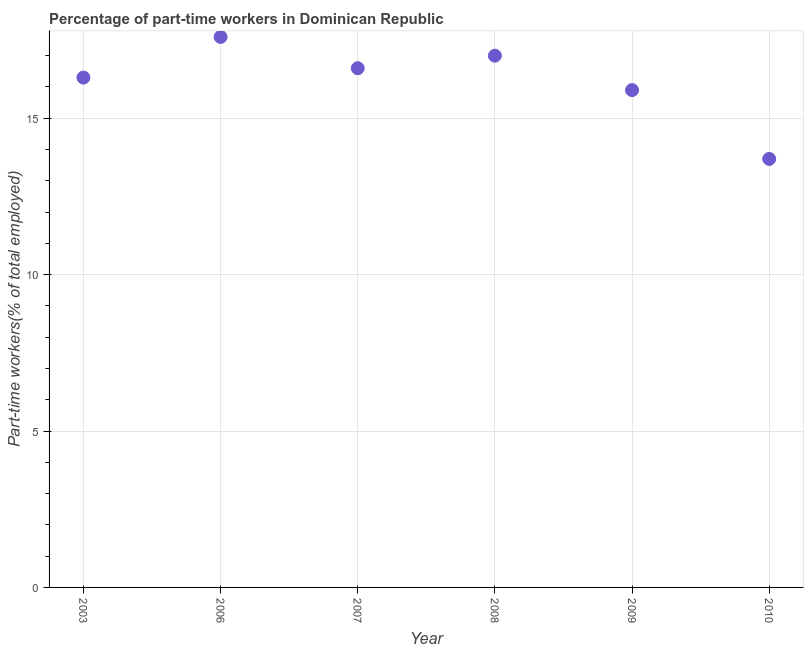Across all years, what is the maximum percentage of part-time workers?
Your answer should be compact. 17.6. Across all years, what is the minimum percentage of part-time workers?
Keep it short and to the point. 13.7. In which year was the percentage of part-time workers minimum?
Offer a terse response. 2010. What is the sum of the percentage of part-time workers?
Provide a succinct answer. 97.1. What is the difference between the percentage of part-time workers in 2003 and 2009?
Provide a short and direct response. 0.4. What is the average percentage of part-time workers per year?
Your answer should be compact. 16.18. What is the median percentage of part-time workers?
Keep it short and to the point. 16.45. Do a majority of the years between 2006 and 2007 (inclusive) have percentage of part-time workers greater than 1 %?
Your answer should be very brief. Yes. What is the ratio of the percentage of part-time workers in 2003 to that in 2007?
Offer a terse response. 0.98. Is the difference between the percentage of part-time workers in 2007 and 2008 greater than the difference between any two years?
Provide a succinct answer. No. What is the difference between the highest and the second highest percentage of part-time workers?
Your response must be concise. 0.6. What is the difference between the highest and the lowest percentage of part-time workers?
Offer a very short reply. 3.9. How many dotlines are there?
Make the answer very short. 1. How many years are there in the graph?
Provide a short and direct response. 6. What is the difference between two consecutive major ticks on the Y-axis?
Offer a terse response. 5. Are the values on the major ticks of Y-axis written in scientific E-notation?
Your answer should be very brief. No. Does the graph contain grids?
Provide a short and direct response. Yes. What is the title of the graph?
Ensure brevity in your answer.  Percentage of part-time workers in Dominican Republic. What is the label or title of the X-axis?
Offer a terse response. Year. What is the label or title of the Y-axis?
Your response must be concise. Part-time workers(% of total employed). What is the Part-time workers(% of total employed) in 2003?
Provide a succinct answer. 16.3. What is the Part-time workers(% of total employed) in 2006?
Ensure brevity in your answer.  17.6. What is the Part-time workers(% of total employed) in 2007?
Provide a short and direct response. 16.6. What is the Part-time workers(% of total employed) in 2008?
Give a very brief answer. 17. What is the Part-time workers(% of total employed) in 2009?
Make the answer very short. 15.9. What is the Part-time workers(% of total employed) in 2010?
Provide a succinct answer. 13.7. What is the difference between the Part-time workers(% of total employed) in 2003 and 2007?
Ensure brevity in your answer.  -0.3. What is the difference between the Part-time workers(% of total employed) in 2006 and 2007?
Provide a short and direct response. 1. What is the difference between the Part-time workers(% of total employed) in 2006 and 2008?
Provide a short and direct response. 0.6. What is the difference between the Part-time workers(% of total employed) in 2006 and 2010?
Keep it short and to the point. 3.9. What is the difference between the Part-time workers(% of total employed) in 2007 and 2008?
Offer a very short reply. -0.4. What is the difference between the Part-time workers(% of total employed) in 2007 and 2009?
Provide a short and direct response. 0.7. What is the difference between the Part-time workers(% of total employed) in 2007 and 2010?
Provide a succinct answer. 2.9. What is the difference between the Part-time workers(% of total employed) in 2008 and 2009?
Make the answer very short. 1.1. What is the difference between the Part-time workers(% of total employed) in 2008 and 2010?
Your answer should be compact. 3.3. What is the difference between the Part-time workers(% of total employed) in 2009 and 2010?
Provide a short and direct response. 2.2. What is the ratio of the Part-time workers(% of total employed) in 2003 to that in 2006?
Offer a very short reply. 0.93. What is the ratio of the Part-time workers(% of total employed) in 2003 to that in 2007?
Provide a short and direct response. 0.98. What is the ratio of the Part-time workers(% of total employed) in 2003 to that in 2010?
Offer a terse response. 1.19. What is the ratio of the Part-time workers(% of total employed) in 2006 to that in 2007?
Your answer should be very brief. 1.06. What is the ratio of the Part-time workers(% of total employed) in 2006 to that in 2008?
Provide a short and direct response. 1.03. What is the ratio of the Part-time workers(% of total employed) in 2006 to that in 2009?
Your answer should be very brief. 1.11. What is the ratio of the Part-time workers(% of total employed) in 2006 to that in 2010?
Your answer should be very brief. 1.28. What is the ratio of the Part-time workers(% of total employed) in 2007 to that in 2009?
Offer a terse response. 1.04. What is the ratio of the Part-time workers(% of total employed) in 2007 to that in 2010?
Your answer should be very brief. 1.21. What is the ratio of the Part-time workers(% of total employed) in 2008 to that in 2009?
Give a very brief answer. 1.07. What is the ratio of the Part-time workers(% of total employed) in 2008 to that in 2010?
Ensure brevity in your answer.  1.24. What is the ratio of the Part-time workers(% of total employed) in 2009 to that in 2010?
Provide a short and direct response. 1.16. 